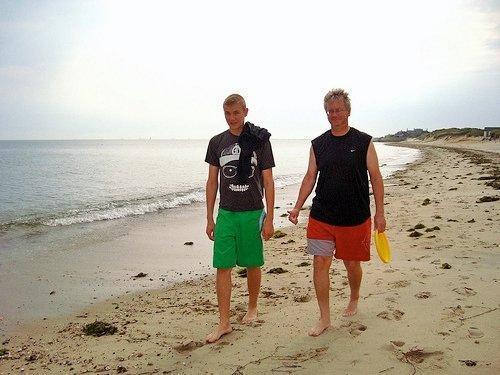How many people are there?
Give a very brief answer. 2. 